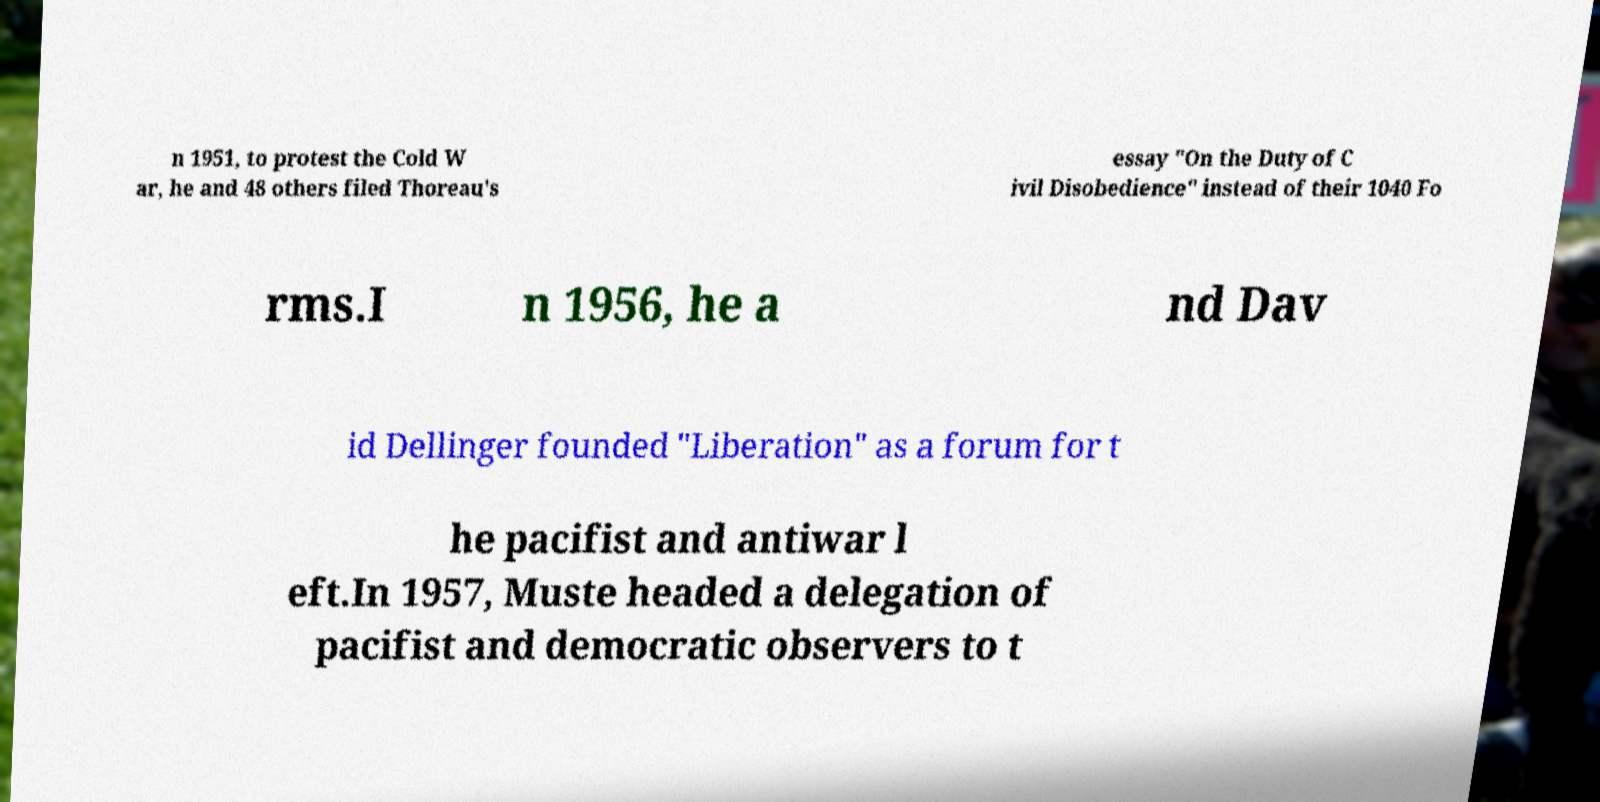There's text embedded in this image that I need extracted. Can you transcribe it verbatim? n 1951, to protest the Cold W ar, he and 48 others filed Thoreau's essay "On the Duty of C ivil Disobedience" instead of their 1040 Fo rms.I n 1956, he a nd Dav id Dellinger founded "Liberation" as a forum for t he pacifist and antiwar l eft.In 1957, Muste headed a delegation of pacifist and democratic observers to t 